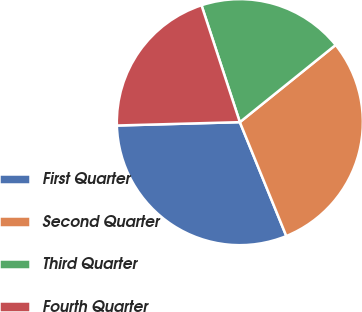Convert chart. <chart><loc_0><loc_0><loc_500><loc_500><pie_chart><fcel>First Quarter<fcel>Second Quarter<fcel>Third Quarter<fcel>Fourth Quarter<nl><fcel>30.73%<fcel>29.63%<fcel>19.25%<fcel>20.39%<nl></chart> 